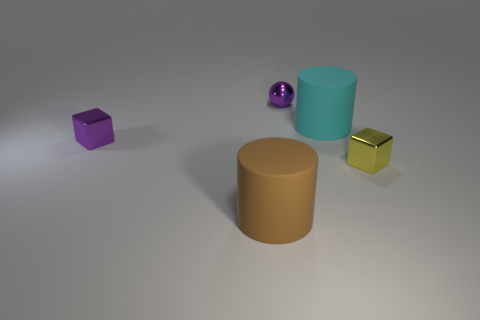How many purple things are behind the large cyan cylinder and on the left side of the brown rubber object?
Ensure brevity in your answer.  0. What number of brown objects are matte objects or big rubber blocks?
Provide a short and direct response. 1. Is the color of the cylinder behind the yellow block the same as the small object behind the large cyan cylinder?
Provide a short and direct response. No. There is a tiny thing that is on the left side of the small purple shiny object behind the big object that is on the right side of the brown matte cylinder; what color is it?
Your answer should be compact. Purple. There is a large rubber cylinder behind the brown cylinder; is there a large brown rubber thing on the right side of it?
Offer a terse response. No. Is the shape of the matte object that is to the left of the cyan cylinder the same as  the big cyan object?
Offer a very short reply. Yes. Is there any other thing that is the same shape as the big cyan object?
Your response must be concise. Yes. What number of spheres are tiny yellow shiny things or tiny green rubber objects?
Ensure brevity in your answer.  0. How many tiny red metallic blocks are there?
Your answer should be very brief. 0. How big is the metallic object behind the metallic object that is to the left of the brown thing?
Ensure brevity in your answer.  Small. 